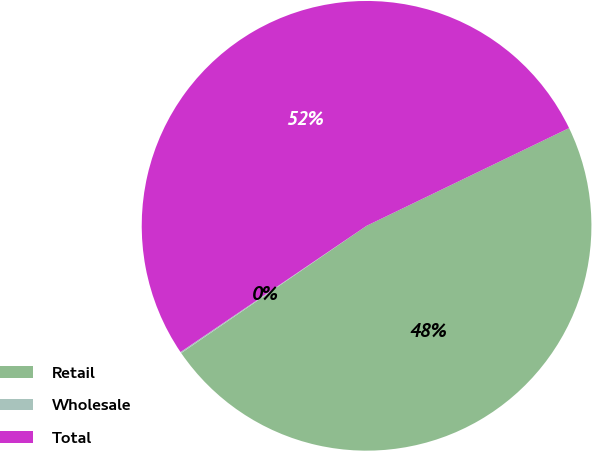Convert chart to OTSL. <chart><loc_0><loc_0><loc_500><loc_500><pie_chart><fcel>Retail<fcel>Wholesale<fcel>Total<nl><fcel>47.58%<fcel>0.09%<fcel>52.33%<nl></chart> 